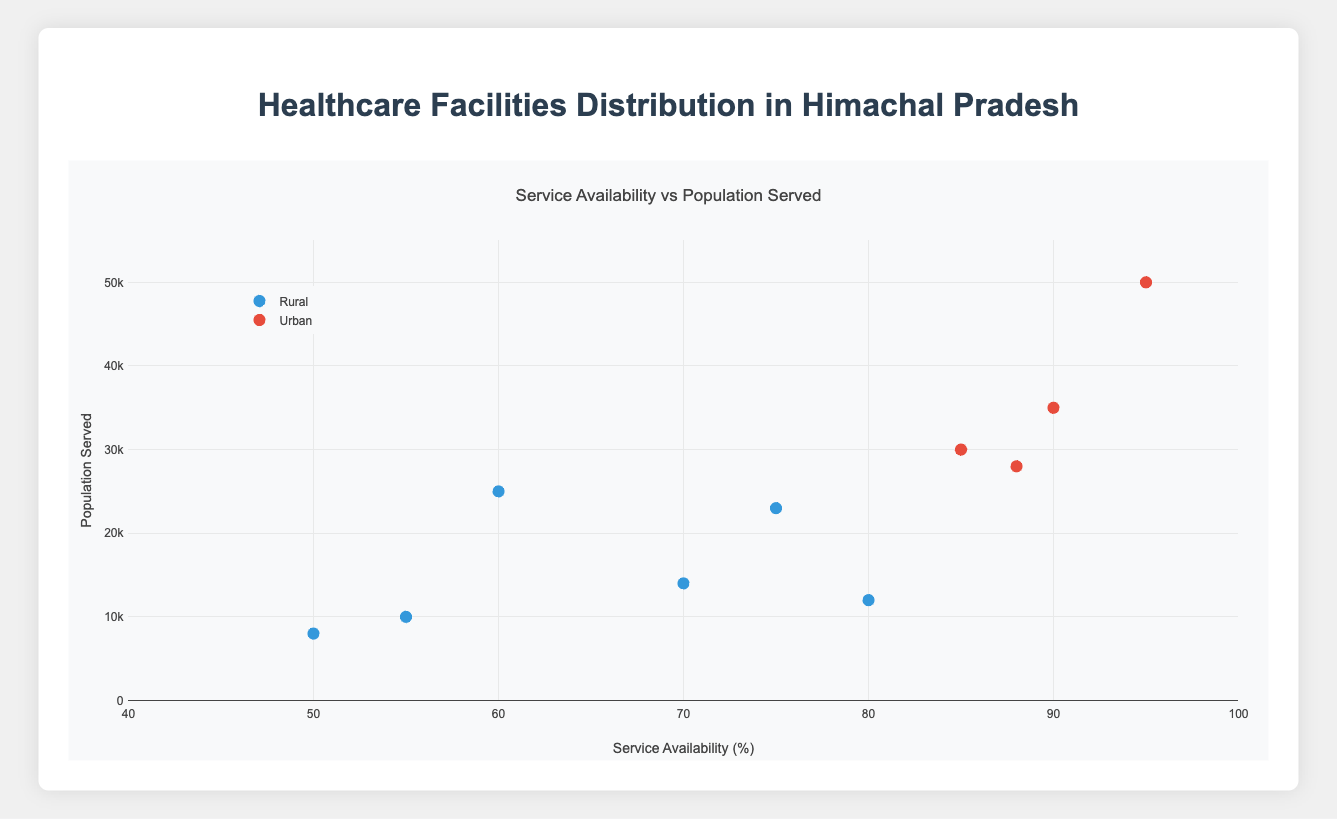Which region has the healthcare facility with the highest service availability? In the scatter plot, observe that the facility with the highest x-axis value (service availability) is in the Urban group. This corresponds to the Zonal Hospital, Shimla with a service availability of 95%.
Answer: Urban Which facility serves the highest population in the rural regions? To determine this, look at the data points in the Rural category and identify the one with the highest y-axis value (population served). The Community Health Center in Kangra serves 25000 people, which is the highest among rural facilities.
Answer: Community Health Center, Kangra What is the average service availability of Primary Health Centers in rural areas? There are two Primary Health Centers in rural areas: Chamba (80%) and Bilaspur (70%). Sum these values and divide by the number of facilities: (80 + 70)/2 = 150/2 = 75%.
Answer: 75% How does the population served by District Hospitals in urban areas compare to those in the rural areas? In urban areas, District Hospitals include Solan (35000) and Mandi (28000). There are no District Hospitals listed in the rural areas for direct comparison. Hence, urban District Hospitals serve 35000 and 28000 individuals respectively.
Answer: Solan serves 35000, Mandi serves 28000 Which facility has the lowest service availability in the urban regions? Look for the data point in the Urban category with the smallest x-axis value. According to the scatter plot, Dharamshala's Civil Hospital has the lowest service availability at 85%.
Answer: Civil Hospital, Dharamshala How many healthcare facilities are available in rural regions? Count the number of data points that belong to the Rural category. There are 5 facilities: Primary Health Center in Chamba, Community Health Center in Kangra, Sub Center in Kullu, Primary Health Center in Bilaspur, and Sub Center in Hamirpur.
Answer: 5 Compare the average population served by healthcare facilities between urban and rural areas. First, calculate the average population served in each region. Urban: (50000 + 35000 + 30000 + 28000)/4 = 143000/4 = 35750. Rural: (12000 + 25000 + 8000 + 14000 + 23000 + 10000)/6 = 92000/6 ≈ 15333.33.
Answer: Urban: 35750, Rural: ~15333.33 Which rural facility has the best service availability, and how does it compare to the best urban facility? The highest service availability in rural areas is for the Primary Health Center in Chamba (80%). The highest in urban areas is the Zonal Hospital, Shimla (95%). Comparing these, the urban facility has a greater service availability.
Answer: Chamba: 80%, Shimla: 95% 